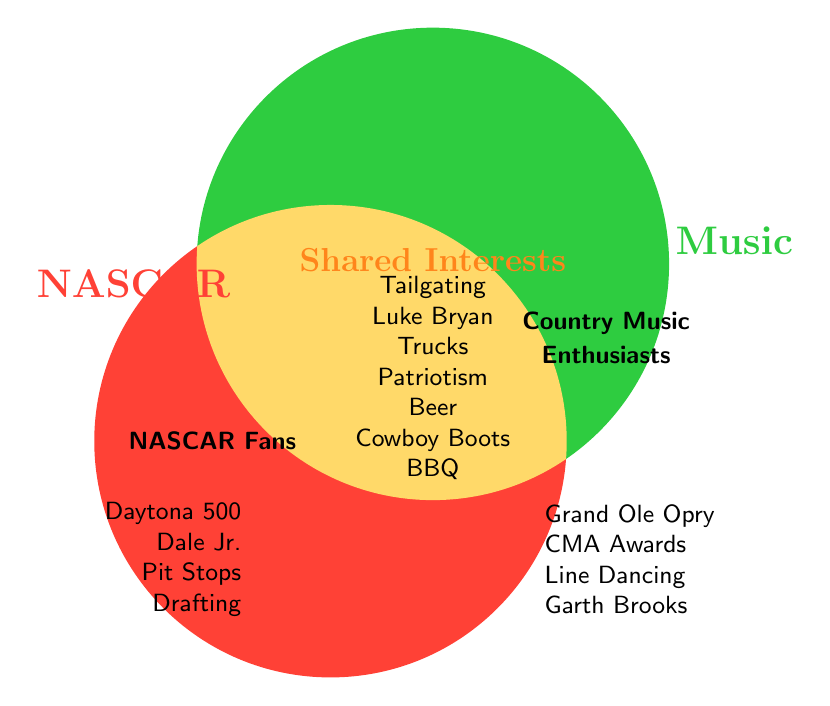What's written in the section only for NASCAR fans? The section only for NASCAR fans lists: Daytona 500, Dale Earnhardt Jr., Pit Stops, and Drafting.
Answer: Daytona 500, Dale Earnhardt Jr., Pit Stops, Drafting Which section includes Tailgating? Tailgating is listed in the overlapping section for both NASCAR fans and Country Music enthusiasts.
Answer: Overlapping section How many interests are shared between NASCAR fans and Country Music enthusiasts? By counting the items in the overlap section: Tailgating, Luke Bryan, Trucks, Patriotism, Beer, Cowboy Boots, BBQ, it totals to seven shared interests.
Answer: Seven Which section includes Grand Ole Opry? Grand Ole Opry is in the section only for Country Music enthusiasts.
Answer: Country Music enthusiasts Are Cowboy Boots exclusive to Country Music enthusiasts? No, Cowboy Boots are listed in the overlapping section, indicating they are shared between both NASCAR fans and Country Music enthusiasts.
Answer: No What's common between the overlapping section and the section only for NASCAR fans? The overlapping section shares Beer with the NASCAR fans section, related to their love for tailgating and BBQ.
Answer: Beer Is Luke Bryan more associated with NASCAR fans? Luke Bryan is in the overlapping section, indicating he is of interest to both NASCAR fans and Country Music enthusiasts.
Answer: No Compare the number of entries unique to NASCAR fans and Country Music enthusiasts. Which has more? NASCAR fans have 4 unique entries: Daytona 500, Dale Jr., Pit Stops, Drafting. Country Music enthusiasts have 5: Grand Ole Opry, CMA Awards, Line Dancing, Garth Brooks, Keith Urban. Thus, Country Music enthusiasts have more.
Answer: Country Music enthusiasts What do the colors represent in the diagram? The red color represents NASCAR fans, the green color represents Country Music enthusiasts, and the orange color represents shared interests.
Answer: Groups and shared interests Are there any shared interests related to food or drinks? Yes, the overlapping section includes Beer and BBQ, both related to food and drinks.
Answer: Yes 